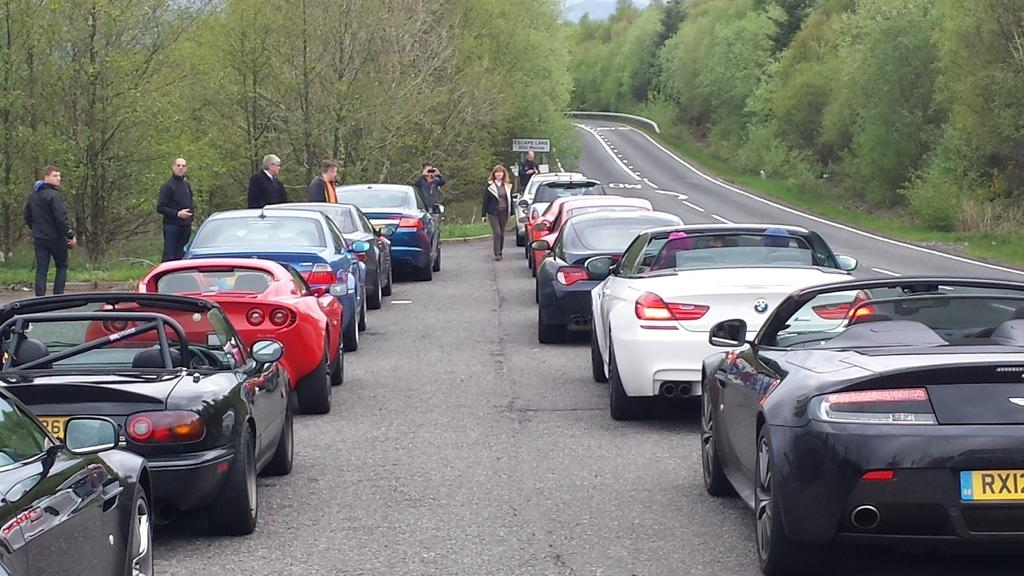Who or what can be seen in the image? There are people in the image. What else is visible on the road in the image? There are vehicles on the road in the image. What type of natural elements can be seen in the image? Trees are visible in the image. Can you describe the structure with a board in the image? A board is attached to poles in the image. Is there a water source visible in the image? There is no water source visible in the image. Can you tell me how many airplanes are parked at the airport in the image? There is no airport or airplanes present in the image. 